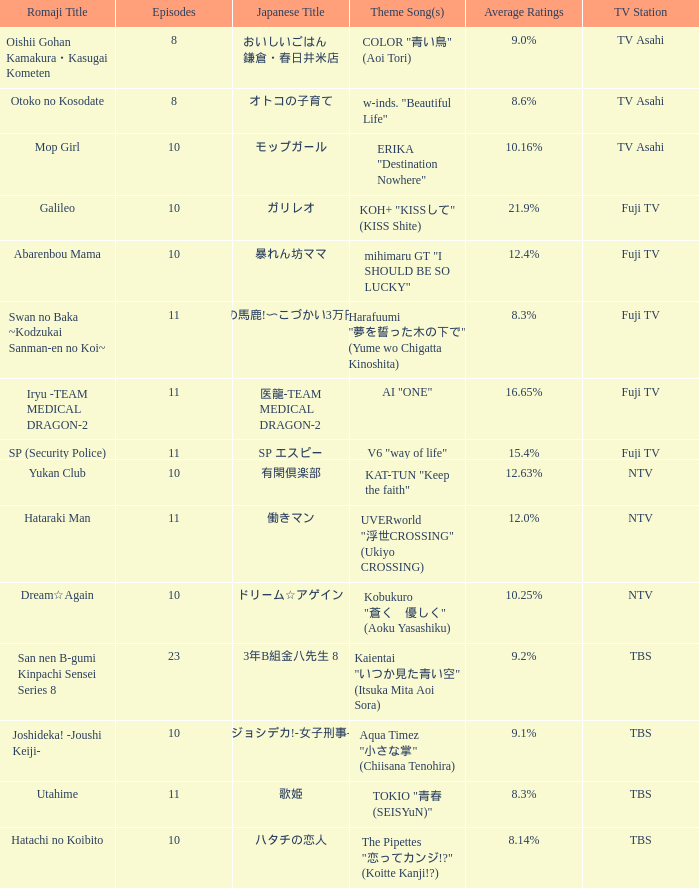What Episode has a Theme Song of koh+ "kissして" (kiss shite)? 10.0. 